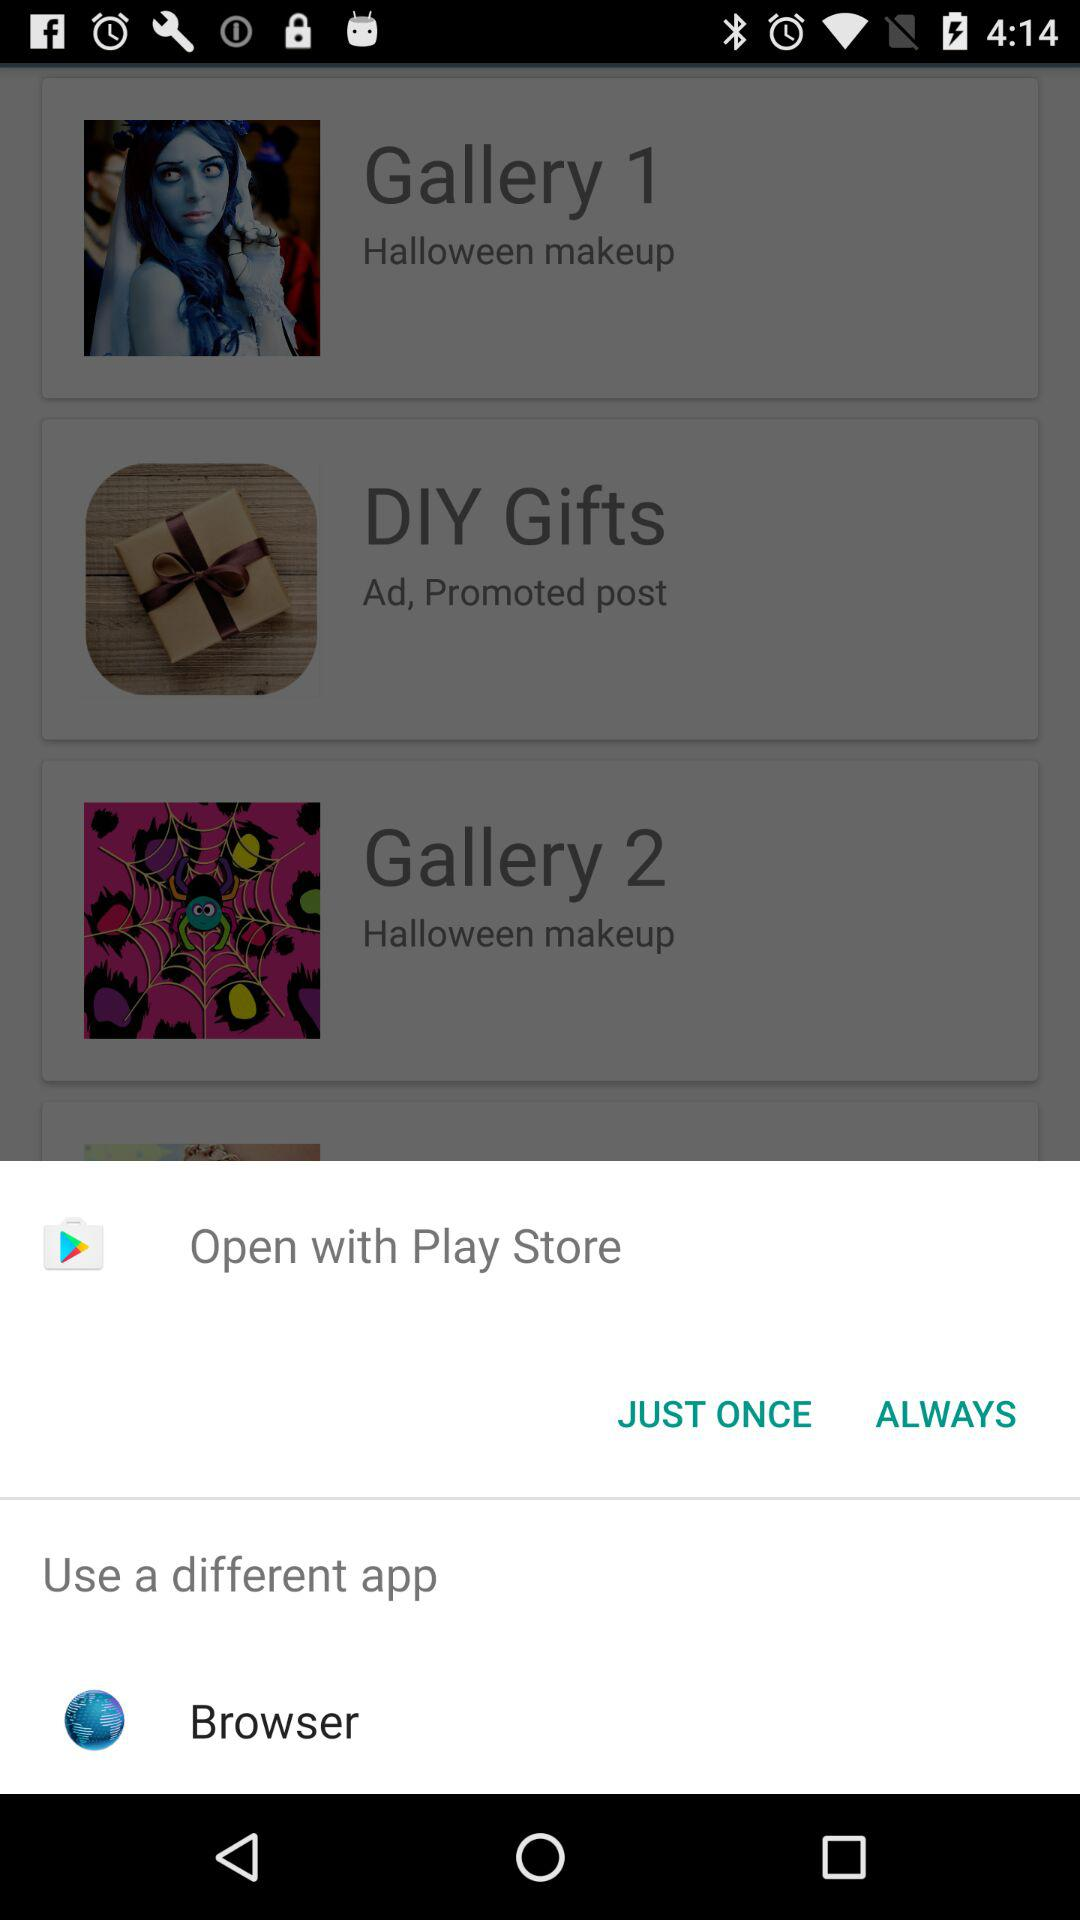Which application is used for open? The applications are "Play Store" and "Browser". 